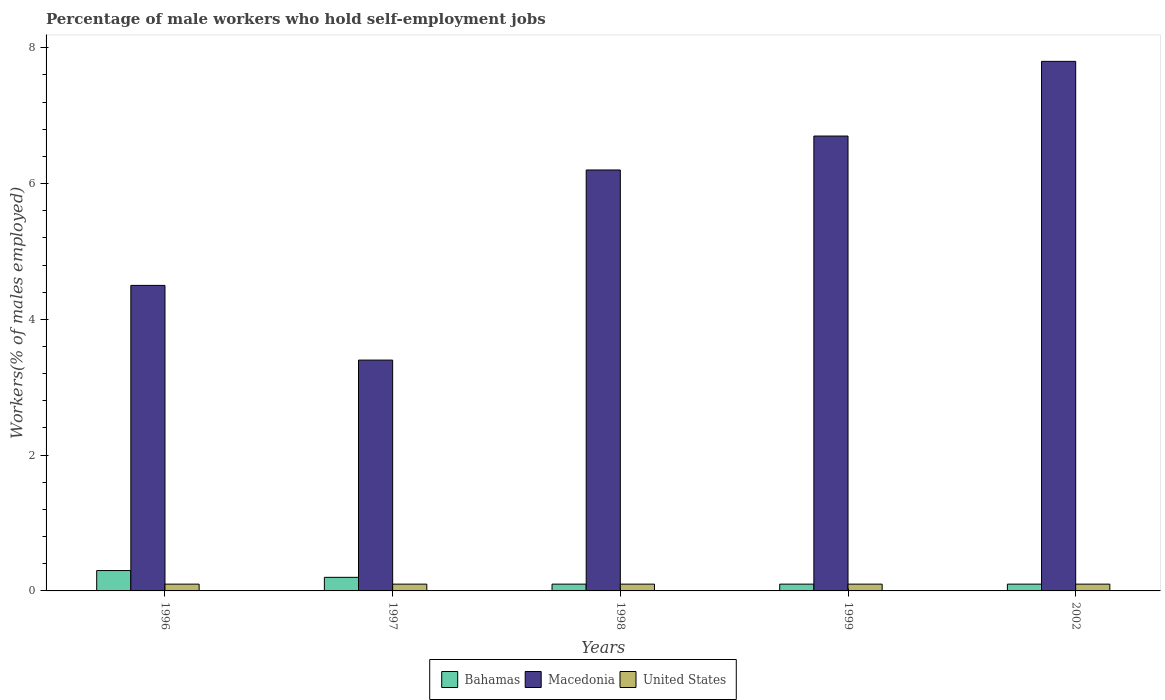How many different coloured bars are there?
Ensure brevity in your answer.  3. Are the number of bars per tick equal to the number of legend labels?
Your response must be concise. Yes. What is the label of the 1st group of bars from the left?
Provide a succinct answer. 1996. In how many cases, is the number of bars for a given year not equal to the number of legend labels?
Offer a terse response. 0. What is the percentage of self-employed male workers in Macedonia in 1996?
Provide a succinct answer. 4.5. Across all years, what is the maximum percentage of self-employed male workers in Macedonia?
Give a very brief answer. 7.8. Across all years, what is the minimum percentage of self-employed male workers in United States?
Ensure brevity in your answer.  0.1. In which year was the percentage of self-employed male workers in Macedonia minimum?
Provide a short and direct response. 1997. What is the total percentage of self-employed male workers in United States in the graph?
Provide a succinct answer. 0.5. What is the difference between the percentage of self-employed male workers in United States in 1998 and that in 1999?
Keep it short and to the point. 0. What is the difference between the percentage of self-employed male workers in United States in 2002 and the percentage of self-employed male workers in Macedonia in 1999?
Ensure brevity in your answer.  -6.6. What is the average percentage of self-employed male workers in Macedonia per year?
Provide a succinct answer. 5.72. In the year 1998, what is the difference between the percentage of self-employed male workers in Macedonia and percentage of self-employed male workers in United States?
Ensure brevity in your answer.  6.1. Is the percentage of self-employed male workers in Macedonia in 1998 less than that in 1999?
Provide a succinct answer. Yes. Is the difference between the percentage of self-employed male workers in Macedonia in 1996 and 1998 greater than the difference between the percentage of self-employed male workers in United States in 1996 and 1998?
Provide a short and direct response. No. What is the difference between the highest and the second highest percentage of self-employed male workers in Macedonia?
Your response must be concise. 1.1. What is the difference between the highest and the lowest percentage of self-employed male workers in United States?
Ensure brevity in your answer.  0. In how many years, is the percentage of self-employed male workers in Bahamas greater than the average percentage of self-employed male workers in Bahamas taken over all years?
Offer a very short reply. 2. Is the sum of the percentage of self-employed male workers in United States in 1998 and 2002 greater than the maximum percentage of self-employed male workers in Bahamas across all years?
Provide a short and direct response. No. What does the 3rd bar from the right in 1999 represents?
Offer a very short reply. Bahamas. Is it the case that in every year, the sum of the percentage of self-employed male workers in United States and percentage of self-employed male workers in Bahamas is greater than the percentage of self-employed male workers in Macedonia?
Offer a very short reply. No. What is the difference between two consecutive major ticks on the Y-axis?
Provide a short and direct response. 2. Are the values on the major ticks of Y-axis written in scientific E-notation?
Give a very brief answer. No. What is the title of the graph?
Provide a succinct answer. Percentage of male workers who hold self-employment jobs. Does "Angola" appear as one of the legend labels in the graph?
Provide a succinct answer. No. What is the label or title of the X-axis?
Give a very brief answer. Years. What is the label or title of the Y-axis?
Your answer should be very brief. Workers(% of males employed). What is the Workers(% of males employed) in Bahamas in 1996?
Provide a short and direct response. 0.3. What is the Workers(% of males employed) in United States in 1996?
Provide a short and direct response. 0.1. What is the Workers(% of males employed) in Bahamas in 1997?
Provide a short and direct response. 0.2. What is the Workers(% of males employed) in Macedonia in 1997?
Keep it short and to the point. 3.4. What is the Workers(% of males employed) in United States in 1997?
Offer a terse response. 0.1. What is the Workers(% of males employed) in Bahamas in 1998?
Provide a succinct answer. 0.1. What is the Workers(% of males employed) of Macedonia in 1998?
Provide a succinct answer. 6.2. What is the Workers(% of males employed) in United States in 1998?
Provide a succinct answer. 0.1. What is the Workers(% of males employed) in Bahamas in 1999?
Your answer should be compact. 0.1. What is the Workers(% of males employed) of Macedonia in 1999?
Your answer should be very brief. 6.7. What is the Workers(% of males employed) in United States in 1999?
Make the answer very short. 0.1. What is the Workers(% of males employed) in Bahamas in 2002?
Your response must be concise. 0.1. What is the Workers(% of males employed) of Macedonia in 2002?
Provide a succinct answer. 7.8. What is the Workers(% of males employed) in United States in 2002?
Provide a succinct answer. 0.1. Across all years, what is the maximum Workers(% of males employed) of Bahamas?
Offer a very short reply. 0.3. Across all years, what is the maximum Workers(% of males employed) of Macedonia?
Ensure brevity in your answer.  7.8. Across all years, what is the maximum Workers(% of males employed) of United States?
Give a very brief answer. 0.1. Across all years, what is the minimum Workers(% of males employed) of Bahamas?
Your answer should be compact. 0.1. Across all years, what is the minimum Workers(% of males employed) in Macedonia?
Provide a succinct answer. 3.4. Across all years, what is the minimum Workers(% of males employed) of United States?
Your answer should be compact. 0.1. What is the total Workers(% of males employed) of Macedonia in the graph?
Offer a terse response. 28.6. What is the total Workers(% of males employed) in United States in the graph?
Make the answer very short. 0.5. What is the difference between the Workers(% of males employed) in Bahamas in 1996 and that in 1997?
Offer a terse response. 0.1. What is the difference between the Workers(% of males employed) in Bahamas in 1996 and that in 1999?
Your answer should be very brief. 0.2. What is the difference between the Workers(% of males employed) of Macedonia in 1996 and that in 1999?
Your answer should be very brief. -2.2. What is the difference between the Workers(% of males employed) of United States in 1996 and that in 1999?
Offer a very short reply. 0. What is the difference between the Workers(% of males employed) of Macedonia in 1997 and that in 1998?
Provide a succinct answer. -2.8. What is the difference between the Workers(% of males employed) in United States in 1997 and that in 1998?
Make the answer very short. 0. What is the difference between the Workers(% of males employed) of Bahamas in 1997 and that in 1999?
Provide a short and direct response. 0.1. What is the difference between the Workers(% of males employed) in Macedonia in 1997 and that in 1999?
Keep it short and to the point. -3.3. What is the difference between the Workers(% of males employed) of Bahamas in 1997 and that in 2002?
Your response must be concise. 0.1. What is the difference between the Workers(% of males employed) in United States in 1997 and that in 2002?
Your answer should be compact. 0. What is the difference between the Workers(% of males employed) of Bahamas in 1998 and that in 1999?
Your response must be concise. 0. What is the difference between the Workers(% of males employed) in United States in 1998 and that in 1999?
Give a very brief answer. 0. What is the difference between the Workers(% of males employed) of Macedonia in 1998 and that in 2002?
Make the answer very short. -1.6. What is the difference between the Workers(% of males employed) of United States in 1998 and that in 2002?
Your answer should be compact. 0. What is the difference between the Workers(% of males employed) in Bahamas in 1999 and that in 2002?
Provide a short and direct response. 0. What is the difference between the Workers(% of males employed) of United States in 1999 and that in 2002?
Offer a terse response. 0. What is the difference between the Workers(% of males employed) of Bahamas in 1996 and the Workers(% of males employed) of Macedonia in 1997?
Provide a short and direct response. -3.1. What is the difference between the Workers(% of males employed) of Bahamas in 1996 and the Workers(% of males employed) of United States in 2002?
Your answer should be compact. 0.2. What is the difference between the Workers(% of males employed) of Bahamas in 1997 and the Workers(% of males employed) of Macedonia in 1999?
Give a very brief answer. -6.5. What is the difference between the Workers(% of males employed) in Macedonia in 1997 and the Workers(% of males employed) in United States in 1999?
Give a very brief answer. 3.3. What is the difference between the Workers(% of males employed) of Bahamas in 1997 and the Workers(% of males employed) of Macedonia in 2002?
Give a very brief answer. -7.6. What is the difference between the Workers(% of males employed) of Bahamas in 1998 and the Workers(% of males employed) of United States in 1999?
Keep it short and to the point. 0. What is the difference between the Workers(% of males employed) of Bahamas in 1998 and the Workers(% of males employed) of Macedonia in 2002?
Offer a very short reply. -7.7. What is the difference between the Workers(% of males employed) in Bahamas in 1998 and the Workers(% of males employed) in United States in 2002?
Provide a short and direct response. 0. What is the difference between the Workers(% of males employed) in Macedonia in 1998 and the Workers(% of males employed) in United States in 2002?
Your answer should be very brief. 6.1. What is the difference between the Workers(% of males employed) of Bahamas in 1999 and the Workers(% of males employed) of Macedonia in 2002?
Offer a terse response. -7.7. What is the difference between the Workers(% of males employed) of Bahamas in 1999 and the Workers(% of males employed) of United States in 2002?
Provide a succinct answer. 0. What is the difference between the Workers(% of males employed) of Macedonia in 1999 and the Workers(% of males employed) of United States in 2002?
Offer a terse response. 6.6. What is the average Workers(% of males employed) in Bahamas per year?
Make the answer very short. 0.16. What is the average Workers(% of males employed) in Macedonia per year?
Make the answer very short. 5.72. In the year 1996, what is the difference between the Workers(% of males employed) in Bahamas and Workers(% of males employed) in Macedonia?
Ensure brevity in your answer.  -4.2. In the year 1997, what is the difference between the Workers(% of males employed) of Bahamas and Workers(% of males employed) of Macedonia?
Make the answer very short. -3.2. In the year 1999, what is the difference between the Workers(% of males employed) of Bahamas and Workers(% of males employed) of Macedonia?
Give a very brief answer. -6.6. In the year 1999, what is the difference between the Workers(% of males employed) in Bahamas and Workers(% of males employed) in United States?
Make the answer very short. 0. In the year 2002, what is the difference between the Workers(% of males employed) of Bahamas and Workers(% of males employed) of Macedonia?
Your answer should be very brief. -7.7. What is the ratio of the Workers(% of males employed) of Bahamas in 1996 to that in 1997?
Offer a terse response. 1.5. What is the ratio of the Workers(% of males employed) in Macedonia in 1996 to that in 1997?
Give a very brief answer. 1.32. What is the ratio of the Workers(% of males employed) of United States in 1996 to that in 1997?
Your answer should be very brief. 1. What is the ratio of the Workers(% of males employed) in Bahamas in 1996 to that in 1998?
Give a very brief answer. 3. What is the ratio of the Workers(% of males employed) of Macedonia in 1996 to that in 1998?
Offer a very short reply. 0.73. What is the ratio of the Workers(% of males employed) in Macedonia in 1996 to that in 1999?
Offer a very short reply. 0.67. What is the ratio of the Workers(% of males employed) of Bahamas in 1996 to that in 2002?
Your answer should be very brief. 3. What is the ratio of the Workers(% of males employed) in Macedonia in 1996 to that in 2002?
Offer a very short reply. 0.58. What is the ratio of the Workers(% of males employed) of United States in 1996 to that in 2002?
Your answer should be very brief. 1. What is the ratio of the Workers(% of males employed) of Macedonia in 1997 to that in 1998?
Your response must be concise. 0.55. What is the ratio of the Workers(% of males employed) in United States in 1997 to that in 1998?
Offer a terse response. 1. What is the ratio of the Workers(% of males employed) in Macedonia in 1997 to that in 1999?
Keep it short and to the point. 0.51. What is the ratio of the Workers(% of males employed) in Macedonia in 1997 to that in 2002?
Offer a terse response. 0.44. What is the ratio of the Workers(% of males employed) in Macedonia in 1998 to that in 1999?
Ensure brevity in your answer.  0.93. What is the ratio of the Workers(% of males employed) of Macedonia in 1998 to that in 2002?
Make the answer very short. 0.79. What is the ratio of the Workers(% of males employed) in Bahamas in 1999 to that in 2002?
Offer a very short reply. 1. What is the ratio of the Workers(% of males employed) of Macedonia in 1999 to that in 2002?
Keep it short and to the point. 0.86. What is the ratio of the Workers(% of males employed) of United States in 1999 to that in 2002?
Keep it short and to the point. 1. What is the difference between the highest and the second highest Workers(% of males employed) of Bahamas?
Ensure brevity in your answer.  0.1. What is the difference between the highest and the second highest Workers(% of males employed) of Macedonia?
Provide a short and direct response. 1.1. What is the difference between the highest and the second highest Workers(% of males employed) of United States?
Provide a short and direct response. 0. What is the difference between the highest and the lowest Workers(% of males employed) in Bahamas?
Offer a very short reply. 0.2. What is the difference between the highest and the lowest Workers(% of males employed) of Macedonia?
Offer a terse response. 4.4. 